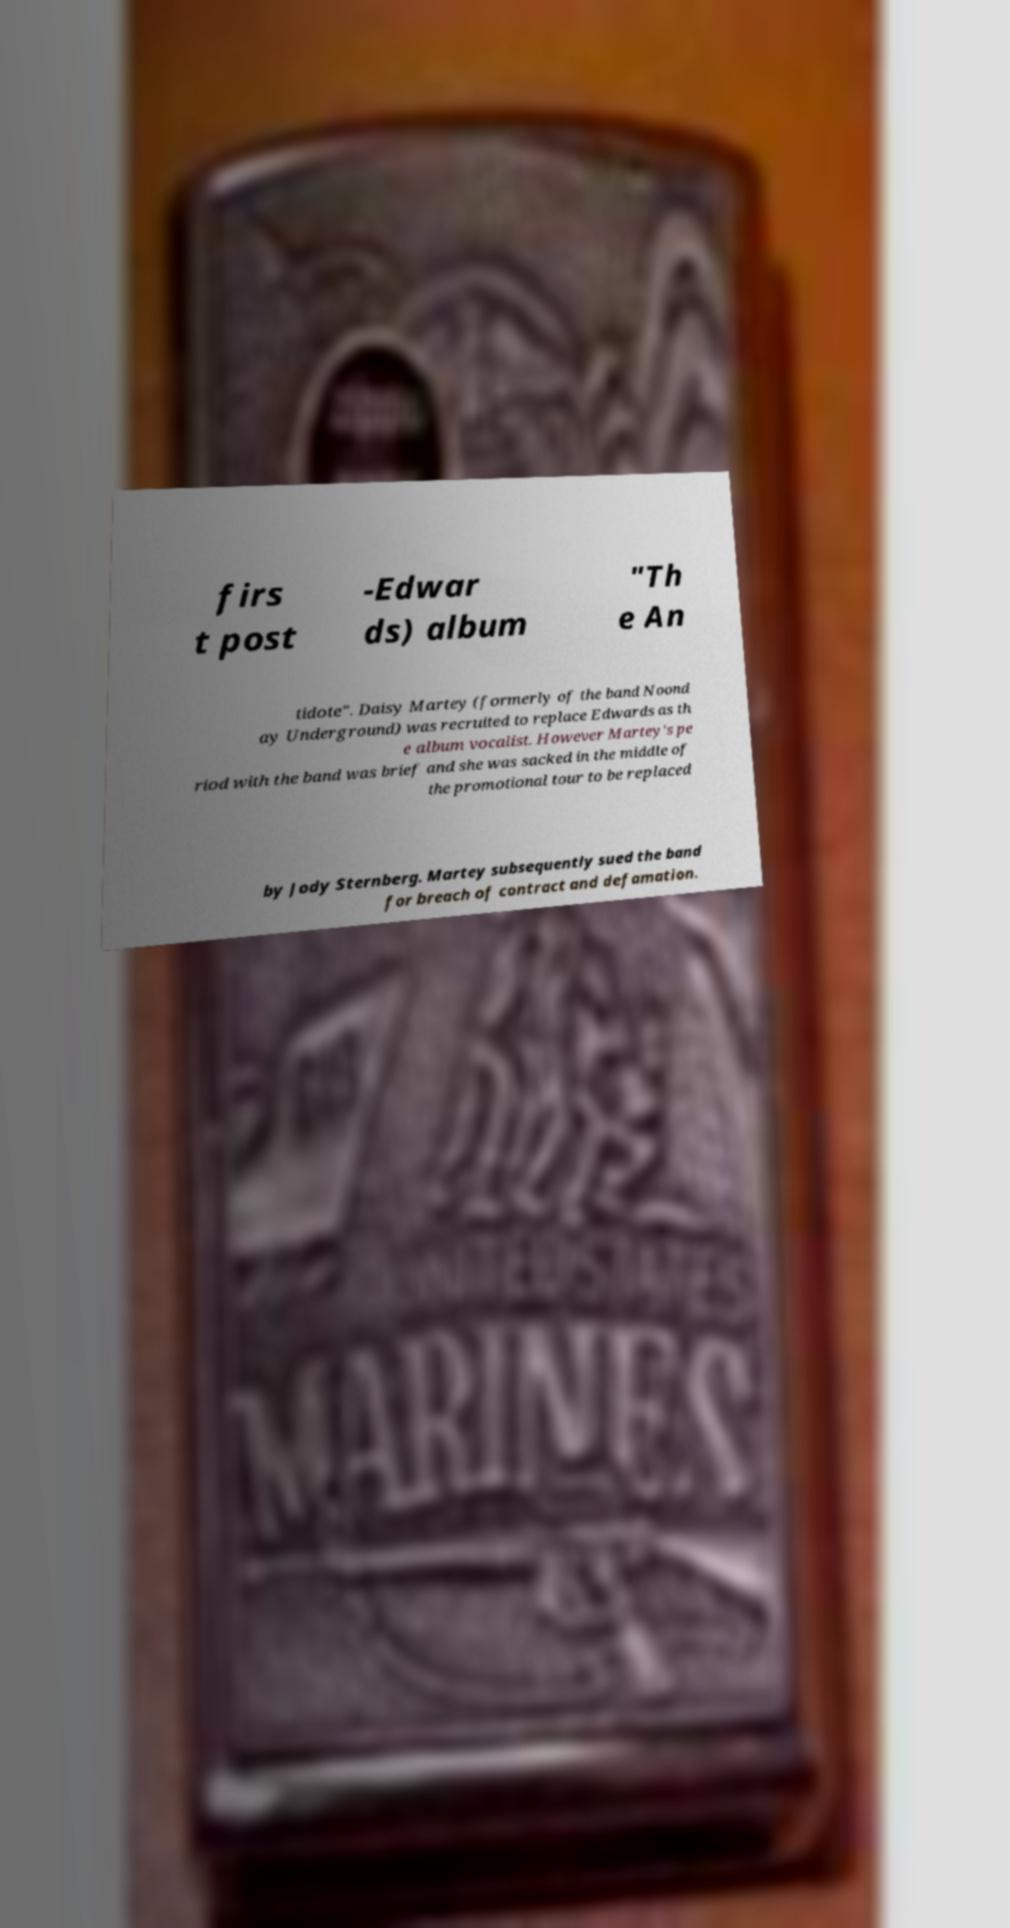What messages or text are displayed in this image? I need them in a readable, typed format. firs t post -Edwar ds) album "Th e An tidote". Daisy Martey (formerly of the band Noond ay Underground) was recruited to replace Edwards as th e album vocalist. However Martey's pe riod with the band was brief and she was sacked in the middle of the promotional tour to be replaced by Jody Sternberg. Martey subsequently sued the band for breach of contract and defamation. 